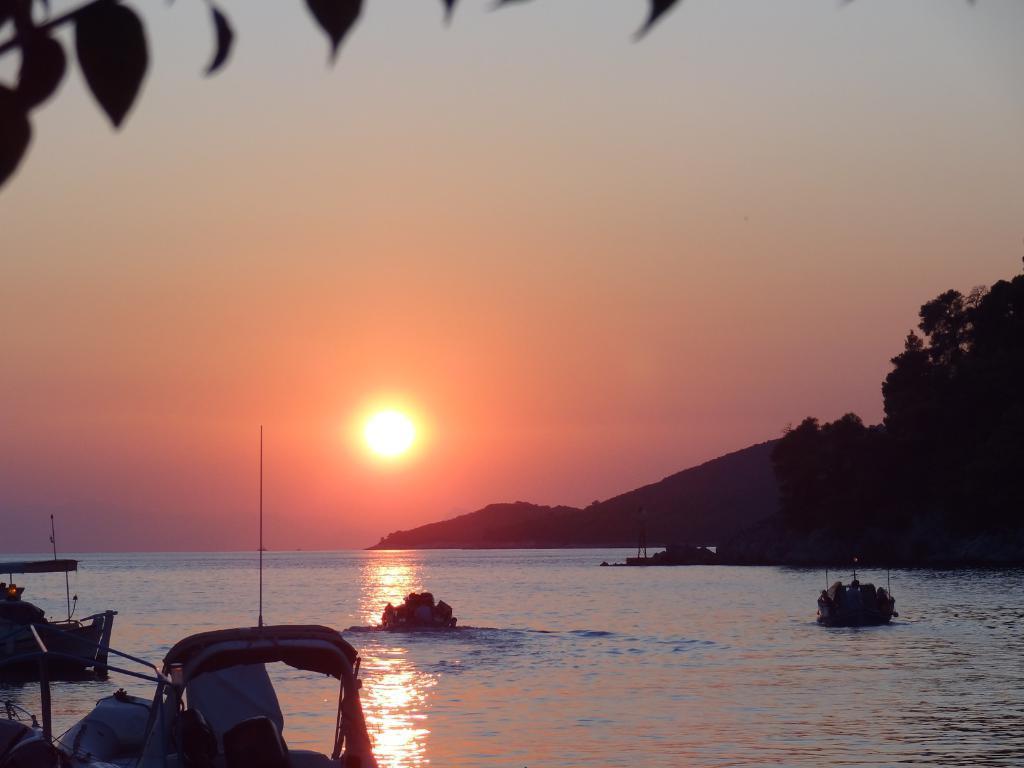How would you summarize this image in a sentence or two? In this image we can see boats on the water and there are poles. In the background there are trees, mountains and sun in the sky. On the left side at the top we can see leaves. 